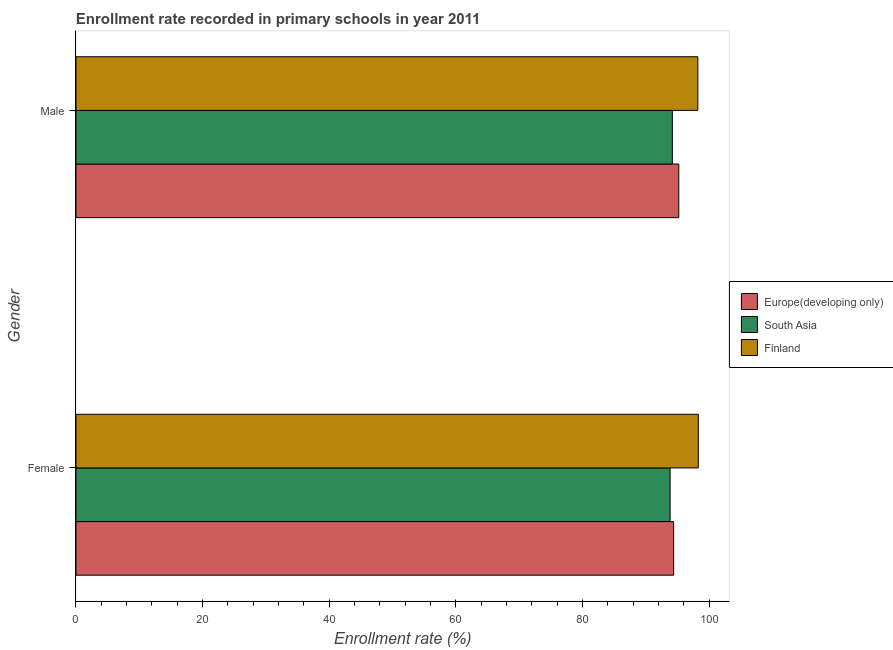How many different coloured bars are there?
Make the answer very short. 3. Are the number of bars per tick equal to the number of legend labels?
Keep it short and to the point. Yes. Are the number of bars on each tick of the Y-axis equal?
Ensure brevity in your answer.  Yes. How many bars are there on the 1st tick from the top?
Provide a succinct answer. 3. How many bars are there on the 1st tick from the bottom?
Make the answer very short. 3. What is the enrollment rate of female students in Europe(developing only)?
Ensure brevity in your answer.  94.4. Across all countries, what is the maximum enrollment rate of female students?
Your answer should be very brief. 98.3. Across all countries, what is the minimum enrollment rate of male students?
Provide a succinct answer. 94.19. What is the total enrollment rate of female students in the graph?
Offer a terse response. 286.54. What is the difference between the enrollment rate of male students in Finland and that in South Asia?
Your answer should be compact. 4.03. What is the difference between the enrollment rate of female students in Finland and the enrollment rate of male students in South Asia?
Offer a very short reply. 4.1. What is the average enrollment rate of female students per country?
Your response must be concise. 95.51. What is the difference between the enrollment rate of male students and enrollment rate of female students in Finland?
Your response must be concise. -0.07. What is the ratio of the enrollment rate of male students in South Asia to that in Finland?
Ensure brevity in your answer.  0.96. Is the enrollment rate of female students in Europe(developing only) less than that in Finland?
Your answer should be very brief. Yes. In how many countries, is the enrollment rate of male students greater than the average enrollment rate of male students taken over all countries?
Your response must be concise. 1. What does the 3rd bar from the top in Female represents?
Offer a terse response. Europe(developing only). What does the 1st bar from the bottom in Female represents?
Your response must be concise. Europe(developing only). How many bars are there?
Your answer should be very brief. 6. How many countries are there in the graph?
Ensure brevity in your answer.  3. What is the difference between two consecutive major ticks on the X-axis?
Keep it short and to the point. 20. Does the graph contain any zero values?
Offer a terse response. No. What is the title of the graph?
Give a very brief answer. Enrollment rate recorded in primary schools in year 2011. Does "Ghana" appear as one of the legend labels in the graph?
Provide a succinct answer. No. What is the label or title of the X-axis?
Make the answer very short. Enrollment rate (%). What is the label or title of the Y-axis?
Your answer should be compact. Gender. What is the Enrollment rate (%) in Europe(developing only) in Female?
Keep it short and to the point. 94.4. What is the Enrollment rate (%) of South Asia in Female?
Offer a very short reply. 93.84. What is the Enrollment rate (%) in Finland in Female?
Provide a short and direct response. 98.3. What is the Enrollment rate (%) of Europe(developing only) in Male?
Give a very brief answer. 95.21. What is the Enrollment rate (%) in South Asia in Male?
Your response must be concise. 94.19. What is the Enrollment rate (%) in Finland in Male?
Offer a terse response. 98.22. Across all Gender, what is the maximum Enrollment rate (%) in Europe(developing only)?
Your response must be concise. 95.21. Across all Gender, what is the maximum Enrollment rate (%) in South Asia?
Offer a terse response. 94.19. Across all Gender, what is the maximum Enrollment rate (%) of Finland?
Offer a very short reply. 98.3. Across all Gender, what is the minimum Enrollment rate (%) of Europe(developing only)?
Keep it short and to the point. 94.4. Across all Gender, what is the minimum Enrollment rate (%) in South Asia?
Your answer should be compact. 93.84. Across all Gender, what is the minimum Enrollment rate (%) in Finland?
Your response must be concise. 98.22. What is the total Enrollment rate (%) in Europe(developing only) in the graph?
Make the answer very short. 189.61. What is the total Enrollment rate (%) in South Asia in the graph?
Make the answer very short. 188.04. What is the total Enrollment rate (%) of Finland in the graph?
Offer a terse response. 196.52. What is the difference between the Enrollment rate (%) of Europe(developing only) in Female and that in Male?
Keep it short and to the point. -0.81. What is the difference between the Enrollment rate (%) in South Asia in Female and that in Male?
Make the answer very short. -0.35. What is the difference between the Enrollment rate (%) of Finland in Female and that in Male?
Your answer should be compact. 0.07. What is the difference between the Enrollment rate (%) of Europe(developing only) in Female and the Enrollment rate (%) of South Asia in Male?
Provide a succinct answer. 0.21. What is the difference between the Enrollment rate (%) in Europe(developing only) in Female and the Enrollment rate (%) in Finland in Male?
Make the answer very short. -3.82. What is the difference between the Enrollment rate (%) of South Asia in Female and the Enrollment rate (%) of Finland in Male?
Your answer should be very brief. -4.38. What is the average Enrollment rate (%) of Europe(developing only) per Gender?
Your answer should be very brief. 94.81. What is the average Enrollment rate (%) of South Asia per Gender?
Your answer should be very brief. 94.02. What is the average Enrollment rate (%) of Finland per Gender?
Make the answer very short. 98.26. What is the difference between the Enrollment rate (%) in Europe(developing only) and Enrollment rate (%) in South Asia in Female?
Your answer should be compact. 0.56. What is the difference between the Enrollment rate (%) in Europe(developing only) and Enrollment rate (%) in Finland in Female?
Provide a succinct answer. -3.89. What is the difference between the Enrollment rate (%) of South Asia and Enrollment rate (%) of Finland in Female?
Offer a very short reply. -4.45. What is the difference between the Enrollment rate (%) in Europe(developing only) and Enrollment rate (%) in South Asia in Male?
Offer a very short reply. 1.02. What is the difference between the Enrollment rate (%) of Europe(developing only) and Enrollment rate (%) of Finland in Male?
Offer a terse response. -3.01. What is the difference between the Enrollment rate (%) in South Asia and Enrollment rate (%) in Finland in Male?
Your response must be concise. -4.03. What is the ratio of the Enrollment rate (%) of Europe(developing only) in Female to that in Male?
Your answer should be compact. 0.99. What is the ratio of the Enrollment rate (%) in South Asia in Female to that in Male?
Your response must be concise. 1. What is the difference between the highest and the second highest Enrollment rate (%) in Europe(developing only)?
Offer a terse response. 0.81. What is the difference between the highest and the second highest Enrollment rate (%) in South Asia?
Your response must be concise. 0.35. What is the difference between the highest and the second highest Enrollment rate (%) of Finland?
Your answer should be compact. 0.07. What is the difference between the highest and the lowest Enrollment rate (%) in Europe(developing only)?
Give a very brief answer. 0.81. What is the difference between the highest and the lowest Enrollment rate (%) of South Asia?
Offer a terse response. 0.35. What is the difference between the highest and the lowest Enrollment rate (%) in Finland?
Provide a succinct answer. 0.07. 